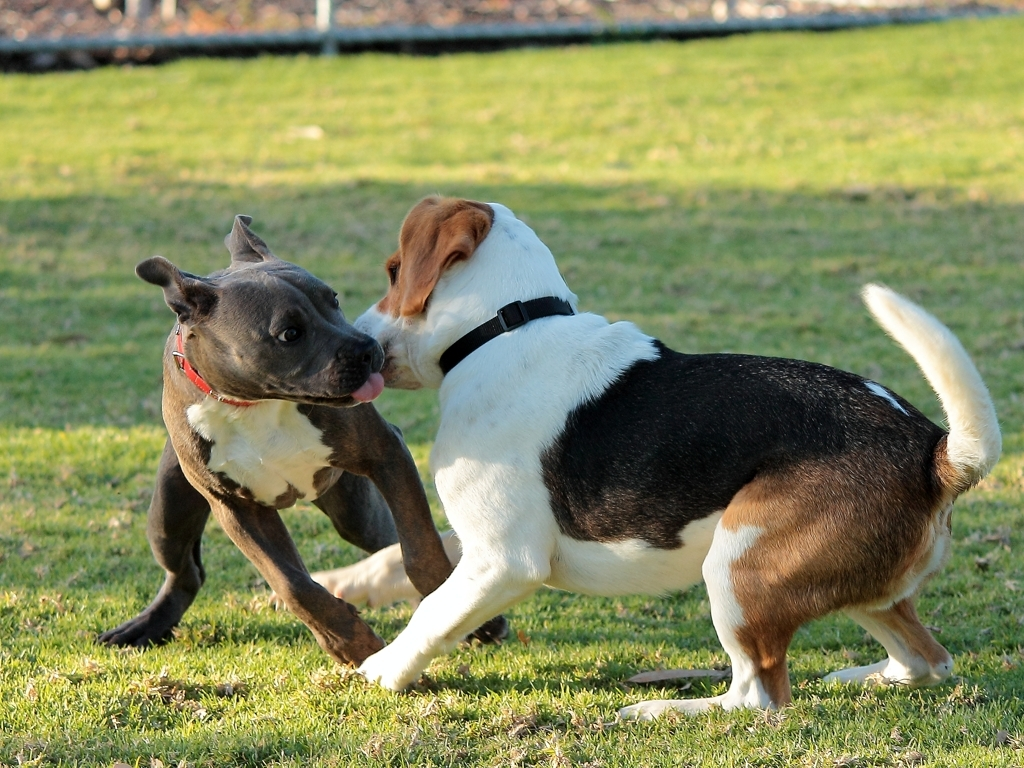What might the body language of the two dogs tell us about their relationship? The body language of these dogs, with their relaxed mouths and engaged play, suggests a positive relationship. They appear to trust each other and have established a rapport that includes rough-and-tumble play. This indicates they are comfortable with each other, potentially signaling a past of frequent friendly interactions, if not a shared living environment. 